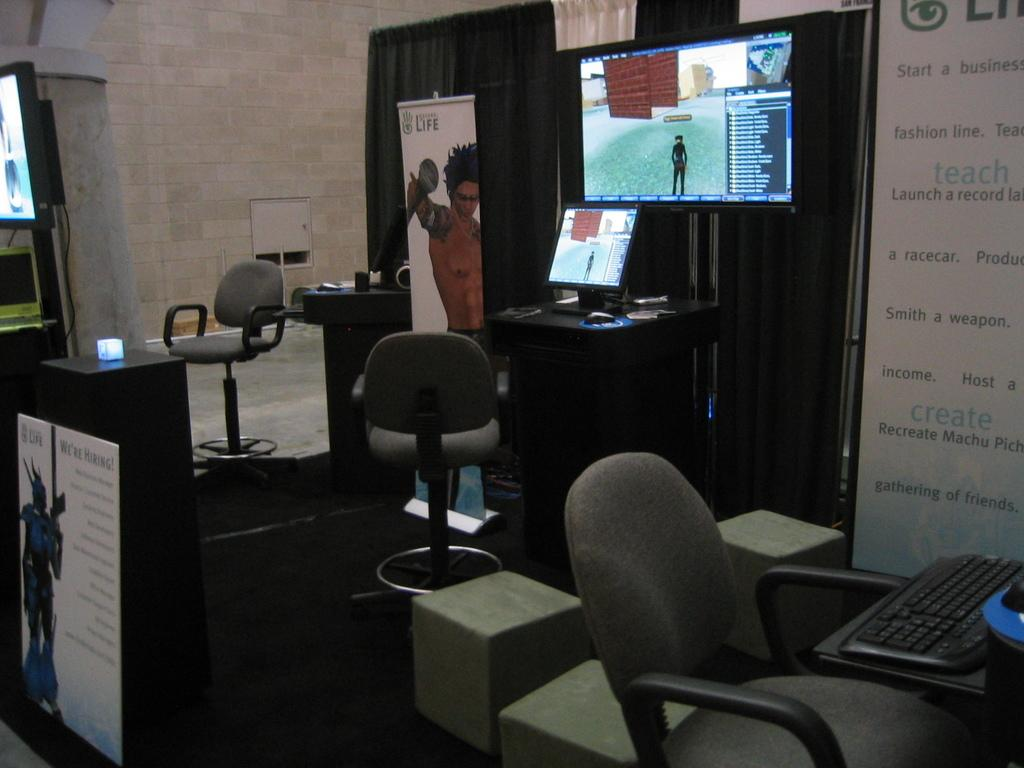What type of structure can be seen in the image? There is a wall in the image. What electronic devices are visible in the image? There are television screens, a monitor, a keyboard, and a mouse in the image. What furniture is present in the image? There are empty chairs and a table in the image. What is on the table in the image? There is a monitor, a mouse, and a mouse pad on the table. What additional decorations or items can be seen in the image? There are banners in the image. What type of glue is being used to hold the yard together in the image? There is no mention of glue, yard, or baseball in the image, so it is not possible to answer that question. 